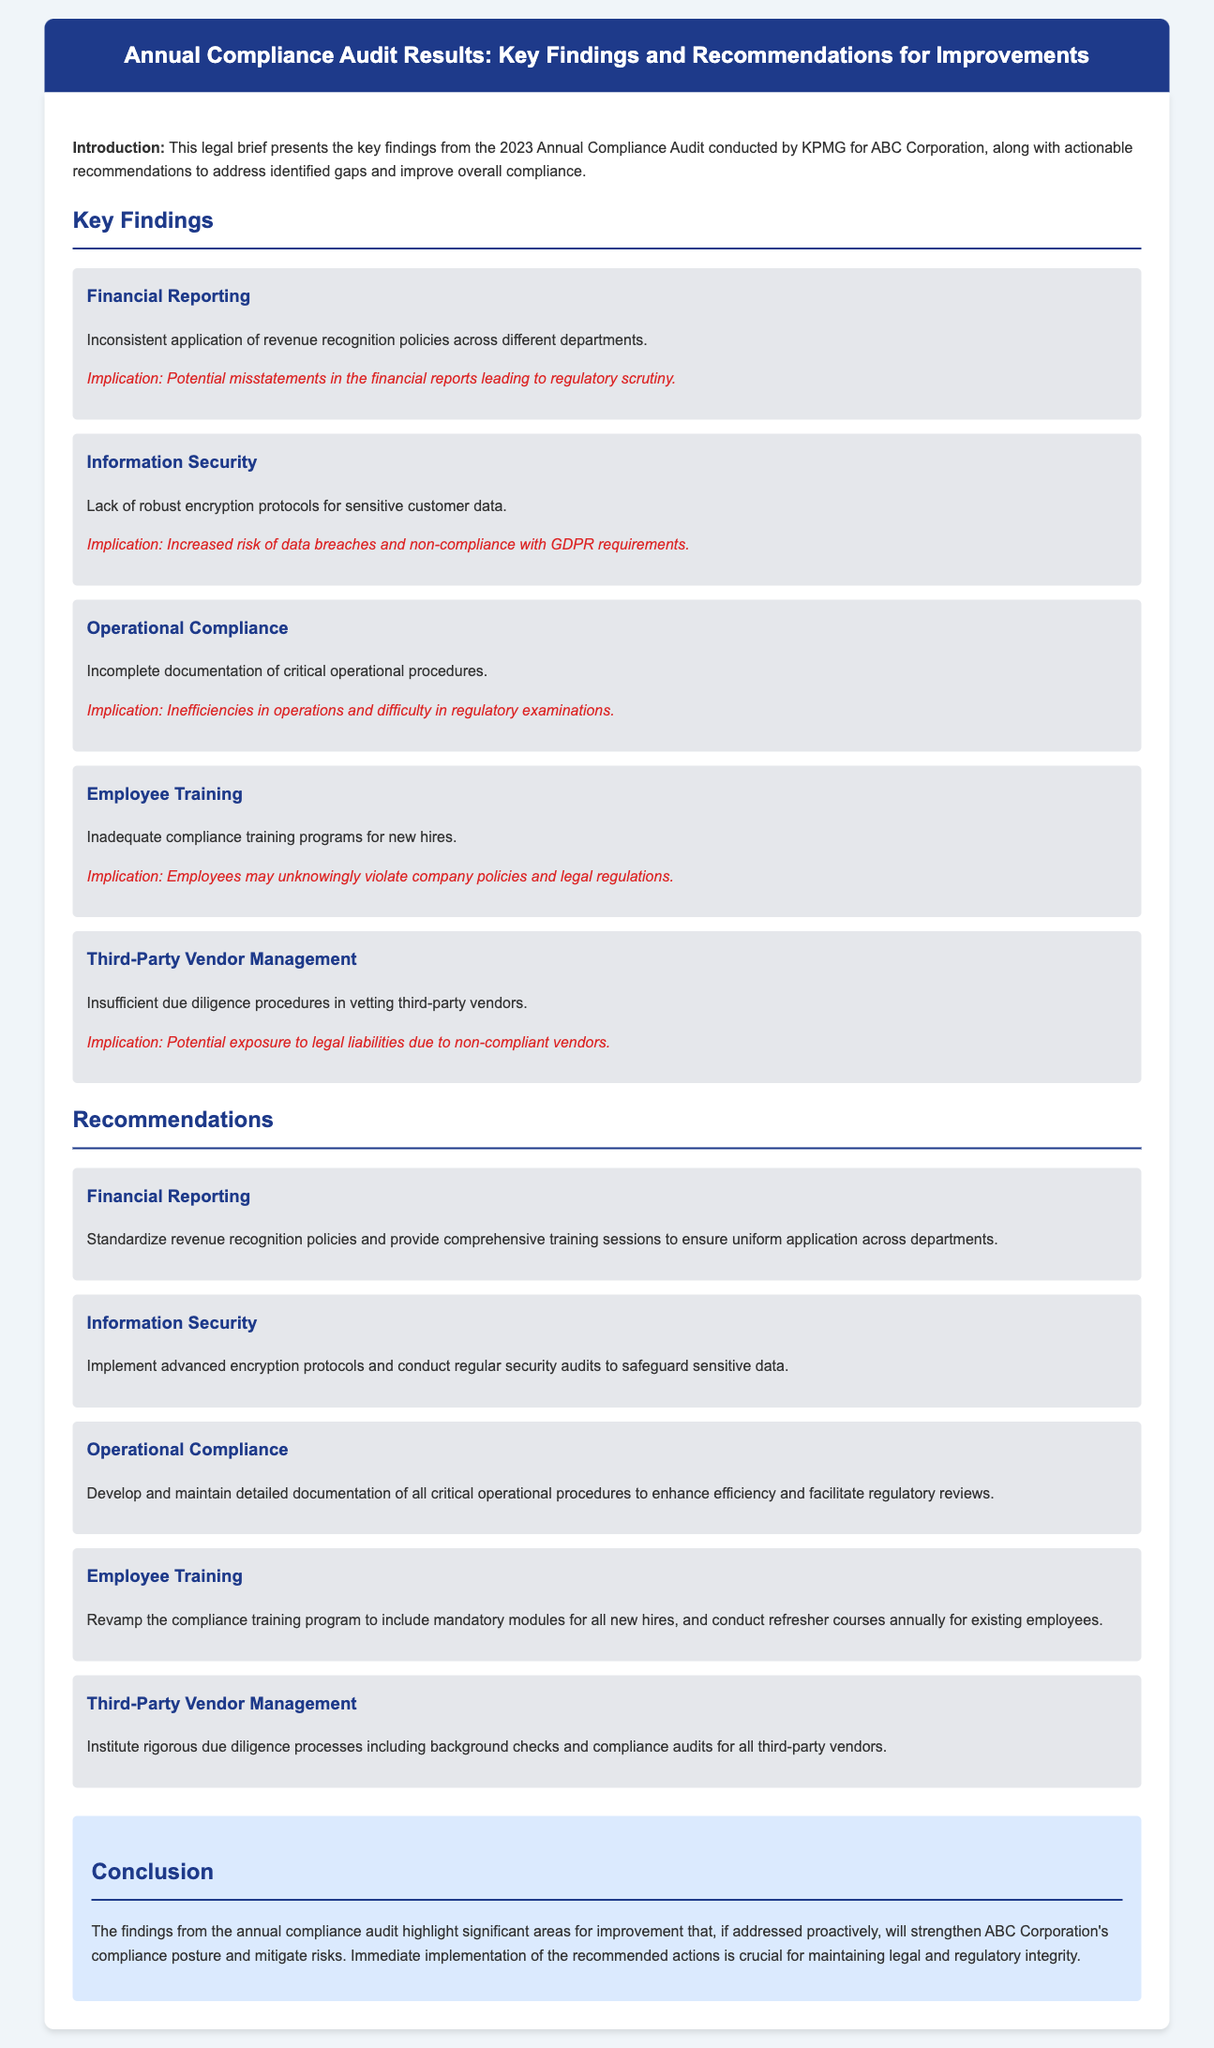What year was the annual compliance audit conducted? The document states the audit was conducted in 2023.
Answer: 2023 What company conducted the audit? The audit was conducted by KPMG for ABC Corporation.
Answer: KPMG What is a key finding related to financial reporting? The finding states there is an inconsistent application of revenue recognition policies across different departments.
Answer: Inconsistent application of revenue recognition policies What recommendation is made for information security? The recommendation is to implement advanced encryption protocols and conduct regular security audits.
Answer: Implement advanced encryption protocols How many key findings are presented in the document? There are a total of five key findings listed.
Answer: Five What is the immediate implication of inadequate employee training? The implication is that employees may unknowingly violate company policies and legal regulations.
Answer: Employees may unknowingly violate company policies What should be done in terms of third-party vendor management? The document recommends instituting rigorous due diligence processes including background checks and compliance audits.
Answer: Institute rigorous due diligence processes What type of document is this? The document is classified as a legal brief.
Answer: Legal brief What is the background color of the header? The header background color is dark blue (#1e3a8a).
Answer: Dark blue 